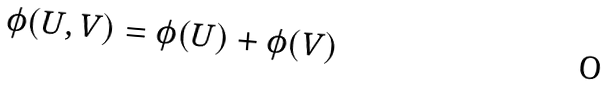Convert formula to latex. <formula><loc_0><loc_0><loc_500><loc_500>\phi ( U , V ) = \phi ( U ) + \phi ( V )</formula> 